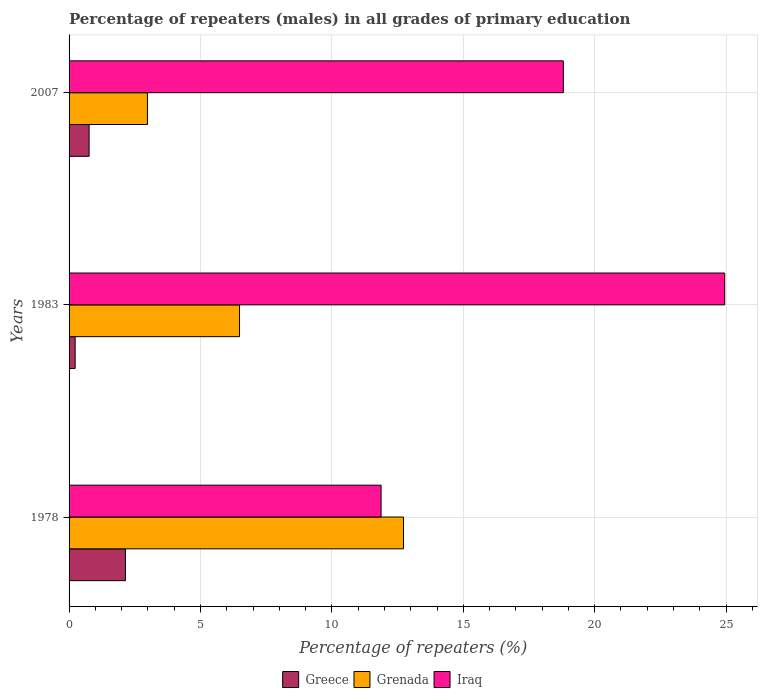How many different coloured bars are there?
Give a very brief answer. 3. Are the number of bars per tick equal to the number of legend labels?
Provide a succinct answer. Yes. Are the number of bars on each tick of the Y-axis equal?
Offer a terse response. Yes. How many bars are there on the 2nd tick from the top?
Make the answer very short. 3. How many bars are there on the 2nd tick from the bottom?
Keep it short and to the point. 3. What is the label of the 3rd group of bars from the top?
Make the answer very short. 1978. What is the percentage of repeaters (males) in Grenada in 1983?
Your answer should be compact. 6.49. Across all years, what is the maximum percentage of repeaters (males) in Grenada?
Offer a terse response. 12.72. Across all years, what is the minimum percentage of repeaters (males) in Iraq?
Make the answer very short. 11.87. In which year was the percentage of repeaters (males) in Grenada maximum?
Offer a very short reply. 1978. What is the total percentage of repeaters (males) in Iraq in the graph?
Your answer should be very brief. 55.63. What is the difference between the percentage of repeaters (males) in Greece in 1978 and that in 2007?
Offer a very short reply. 1.38. What is the difference between the percentage of repeaters (males) in Greece in 1978 and the percentage of repeaters (males) in Iraq in 1983?
Provide a short and direct response. -22.8. What is the average percentage of repeaters (males) in Grenada per year?
Keep it short and to the point. 7.4. In the year 2007, what is the difference between the percentage of repeaters (males) in Greece and percentage of repeaters (males) in Grenada?
Your response must be concise. -2.22. In how many years, is the percentage of repeaters (males) in Grenada greater than 3 %?
Offer a terse response. 2. What is the ratio of the percentage of repeaters (males) in Grenada in 1983 to that in 2007?
Offer a very short reply. 2.17. Is the percentage of repeaters (males) in Greece in 1978 less than that in 1983?
Your answer should be very brief. No. Is the difference between the percentage of repeaters (males) in Greece in 1978 and 1983 greater than the difference between the percentage of repeaters (males) in Grenada in 1978 and 1983?
Make the answer very short. No. What is the difference between the highest and the second highest percentage of repeaters (males) in Iraq?
Ensure brevity in your answer.  6.14. What is the difference between the highest and the lowest percentage of repeaters (males) in Greece?
Your response must be concise. 1.91. What does the 1st bar from the top in 2007 represents?
Make the answer very short. Iraq. How many bars are there?
Offer a terse response. 9. Are all the bars in the graph horizontal?
Make the answer very short. Yes. How many years are there in the graph?
Your response must be concise. 3. What is the difference between two consecutive major ticks on the X-axis?
Give a very brief answer. 5. Does the graph contain grids?
Your response must be concise. Yes. Where does the legend appear in the graph?
Give a very brief answer. Bottom center. How many legend labels are there?
Provide a short and direct response. 3. What is the title of the graph?
Your answer should be very brief. Percentage of repeaters (males) in all grades of primary education. What is the label or title of the X-axis?
Provide a short and direct response. Percentage of repeaters (%). What is the Percentage of repeaters (%) in Greece in 1978?
Keep it short and to the point. 2.14. What is the Percentage of repeaters (%) in Grenada in 1978?
Ensure brevity in your answer.  12.72. What is the Percentage of repeaters (%) in Iraq in 1978?
Provide a short and direct response. 11.87. What is the Percentage of repeaters (%) of Greece in 1983?
Keep it short and to the point. 0.23. What is the Percentage of repeaters (%) of Grenada in 1983?
Your response must be concise. 6.49. What is the Percentage of repeaters (%) in Iraq in 1983?
Give a very brief answer. 24.95. What is the Percentage of repeaters (%) in Greece in 2007?
Offer a terse response. 0.76. What is the Percentage of repeaters (%) in Grenada in 2007?
Ensure brevity in your answer.  2.98. What is the Percentage of repeaters (%) in Iraq in 2007?
Provide a succinct answer. 18.81. Across all years, what is the maximum Percentage of repeaters (%) of Greece?
Offer a very short reply. 2.14. Across all years, what is the maximum Percentage of repeaters (%) of Grenada?
Give a very brief answer. 12.72. Across all years, what is the maximum Percentage of repeaters (%) of Iraq?
Offer a very short reply. 24.95. Across all years, what is the minimum Percentage of repeaters (%) of Greece?
Offer a terse response. 0.23. Across all years, what is the minimum Percentage of repeaters (%) of Grenada?
Keep it short and to the point. 2.98. Across all years, what is the minimum Percentage of repeaters (%) in Iraq?
Keep it short and to the point. 11.87. What is the total Percentage of repeaters (%) of Greece in the graph?
Your answer should be very brief. 3.14. What is the total Percentage of repeaters (%) of Grenada in the graph?
Offer a terse response. 22.19. What is the total Percentage of repeaters (%) of Iraq in the graph?
Offer a terse response. 55.63. What is the difference between the Percentage of repeaters (%) in Greece in 1978 and that in 1983?
Your answer should be very brief. 1.91. What is the difference between the Percentage of repeaters (%) of Grenada in 1978 and that in 1983?
Keep it short and to the point. 6.24. What is the difference between the Percentage of repeaters (%) in Iraq in 1978 and that in 1983?
Ensure brevity in your answer.  -13.08. What is the difference between the Percentage of repeaters (%) of Greece in 1978 and that in 2007?
Give a very brief answer. 1.38. What is the difference between the Percentage of repeaters (%) of Grenada in 1978 and that in 2007?
Offer a terse response. 9.74. What is the difference between the Percentage of repeaters (%) of Iraq in 1978 and that in 2007?
Keep it short and to the point. -6.94. What is the difference between the Percentage of repeaters (%) of Greece in 1983 and that in 2007?
Your answer should be compact. -0.53. What is the difference between the Percentage of repeaters (%) of Grenada in 1983 and that in 2007?
Offer a very short reply. 3.5. What is the difference between the Percentage of repeaters (%) in Iraq in 1983 and that in 2007?
Ensure brevity in your answer.  6.14. What is the difference between the Percentage of repeaters (%) in Greece in 1978 and the Percentage of repeaters (%) in Grenada in 1983?
Make the answer very short. -4.34. What is the difference between the Percentage of repeaters (%) of Greece in 1978 and the Percentage of repeaters (%) of Iraq in 1983?
Offer a very short reply. -22.8. What is the difference between the Percentage of repeaters (%) in Grenada in 1978 and the Percentage of repeaters (%) in Iraq in 1983?
Provide a succinct answer. -12.22. What is the difference between the Percentage of repeaters (%) of Greece in 1978 and the Percentage of repeaters (%) of Grenada in 2007?
Ensure brevity in your answer.  -0.84. What is the difference between the Percentage of repeaters (%) of Greece in 1978 and the Percentage of repeaters (%) of Iraq in 2007?
Offer a very short reply. -16.66. What is the difference between the Percentage of repeaters (%) of Grenada in 1978 and the Percentage of repeaters (%) of Iraq in 2007?
Offer a terse response. -6.08. What is the difference between the Percentage of repeaters (%) of Greece in 1983 and the Percentage of repeaters (%) of Grenada in 2007?
Keep it short and to the point. -2.75. What is the difference between the Percentage of repeaters (%) in Greece in 1983 and the Percentage of repeaters (%) in Iraq in 2007?
Provide a succinct answer. -18.58. What is the difference between the Percentage of repeaters (%) in Grenada in 1983 and the Percentage of repeaters (%) in Iraq in 2007?
Offer a terse response. -12.32. What is the average Percentage of repeaters (%) of Greece per year?
Offer a very short reply. 1.05. What is the average Percentage of repeaters (%) of Grenada per year?
Provide a short and direct response. 7.4. What is the average Percentage of repeaters (%) of Iraq per year?
Your answer should be compact. 18.54. In the year 1978, what is the difference between the Percentage of repeaters (%) of Greece and Percentage of repeaters (%) of Grenada?
Offer a very short reply. -10.58. In the year 1978, what is the difference between the Percentage of repeaters (%) in Greece and Percentage of repeaters (%) in Iraq?
Your answer should be very brief. -9.73. In the year 1978, what is the difference between the Percentage of repeaters (%) of Grenada and Percentage of repeaters (%) of Iraq?
Your response must be concise. 0.85. In the year 1983, what is the difference between the Percentage of repeaters (%) in Greece and Percentage of repeaters (%) in Grenada?
Ensure brevity in your answer.  -6.25. In the year 1983, what is the difference between the Percentage of repeaters (%) in Greece and Percentage of repeaters (%) in Iraq?
Give a very brief answer. -24.72. In the year 1983, what is the difference between the Percentage of repeaters (%) in Grenada and Percentage of repeaters (%) in Iraq?
Provide a short and direct response. -18.46. In the year 2007, what is the difference between the Percentage of repeaters (%) of Greece and Percentage of repeaters (%) of Grenada?
Your answer should be compact. -2.22. In the year 2007, what is the difference between the Percentage of repeaters (%) of Greece and Percentage of repeaters (%) of Iraq?
Ensure brevity in your answer.  -18.04. In the year 2007, what is the difference between the Percentage of repeaters (%) in Grenada and Percentage of repeaters (%) in Iraq?
Your response must be concise. -15.82. What is the ratio of the Percentage of repeaters (%) in Greece in 1978 to that in 1983?
Provide a succinct answer. 9.26. What is the ratio of the Percentage of repeaters (%) of Grenada in 1978 to that in 1983?
Your answer should be compact. 1.96. What is the ratio of the Percentage of repeaters (%) of Iraq in 1978 to that in 1983?
Give a very brief answer. 0.48. What is the ratio of the Percentage of repeaters (%) of Greece in 1978 to that in 2007?
Your answer should be compact. 2.81. What is the ratio of the Percentage of repeaters (%) of Grenada in 1978 to that in 2007?
Provide a succinct answer. 4.27. What is the ratio of the Percentage of repeaters (%) in Iraq in 1978 to that in 2007?
Ensure brevity in your answer.  0.63. What is the ratio of the Percentage of repeaters (%) in Greece in 1983 to that in 2007?
Your answer should be very brief. 0.3. What is the ratio of the Percentage of repeaters (%) in Grenada in 1983 to that in 2007?
Keep it short and to the point. 2.17. What is the ratio of the Percentage of repeaters (%) of Iraq in 1983 to that in 2007?
Your response must be concise. 1.33. What is the difference between the highest and the second highest Percentage of repeaters (%) of Greece?
Provide a short and direct response. 1.38. What is the difference between the highest and the second highest Percentage of repeaters (%) of Grenada?
Your response must be concise. 6.24. What is the difference between the highest and the second highest Percentage of repeaters (%) in Iraq?
Offer a terse response. 6.14. What is the difference between the highest and the lowest Percentage of repeaters (%) in Greece?
Offer a terse response. 1.91. What is the difference between the highest and the lowest Percentage of repeaters (%) of Grenada?
Make the answer very short. 9.74. What is the difference between the highest and the lowest Percentage of repeaters (%) in Iraq?
Give a very brief answer. 13.08. 